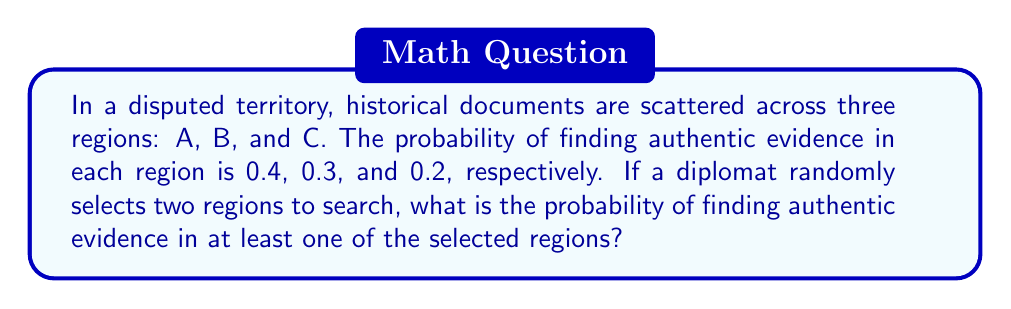Could you help me with this problem? To solve this problem, we'll use the concept of probability of union of events and the complement rule.

Let's define the events:
A: Finding authentic evidence in region A
B: Finding authentic evidence in region B
C: Finding authentic evidence in region C

Given probabilities:
P(A) = 0.4
P(B) = 0.3
P(C) = 0.2

Step 1: Calculate the probability of not finding evidence in each region:
P(not A) = 1 - P(A) = 1 - 0.4 = 0.6
P(not B) = 1 - P(B) = 1 - 0.3 = 0.7
P(not C) = 1 - P(C) = 1 - 0.2 = 0.8

Step 2: Calculate the probability of not finding evidence in any two selected regions:
P(not finding evidence) = $\frac{P(\text{not A and not B}) + P(\text{not A and not C}) + P(\text{not B and not C})}{3}$

Step 3: Apply the multiplication rule for independent events:
P(not finding evidence) = $\frac{(0.6 \times 0.7) + (0.6 \times 0.8) + (0.7 \times 0.8)}{3}$

Step 4: Compute the result:
P(not finding evidence) = $\frac{0.42 + 0.48 + 0.56}{3} = \frac{1.46}{3} \approx 0.4867$

Step 5: Apply the complement rule to find the probability of finding evidence in at least one region:
P(finding evidence) = 1 - P(not finding evidence)
P(finding evidence) = 1 - 0.4867 = 0.5133

Therefore, the probability of finding authentic evidence in at least one of the two randomly selected regions is approximately 0.5133 or 51.33%.
Answer: The probability of finding authentic evidence in at least one of the two randomly selected regions is approximately 0.5133 or 51.33%. 